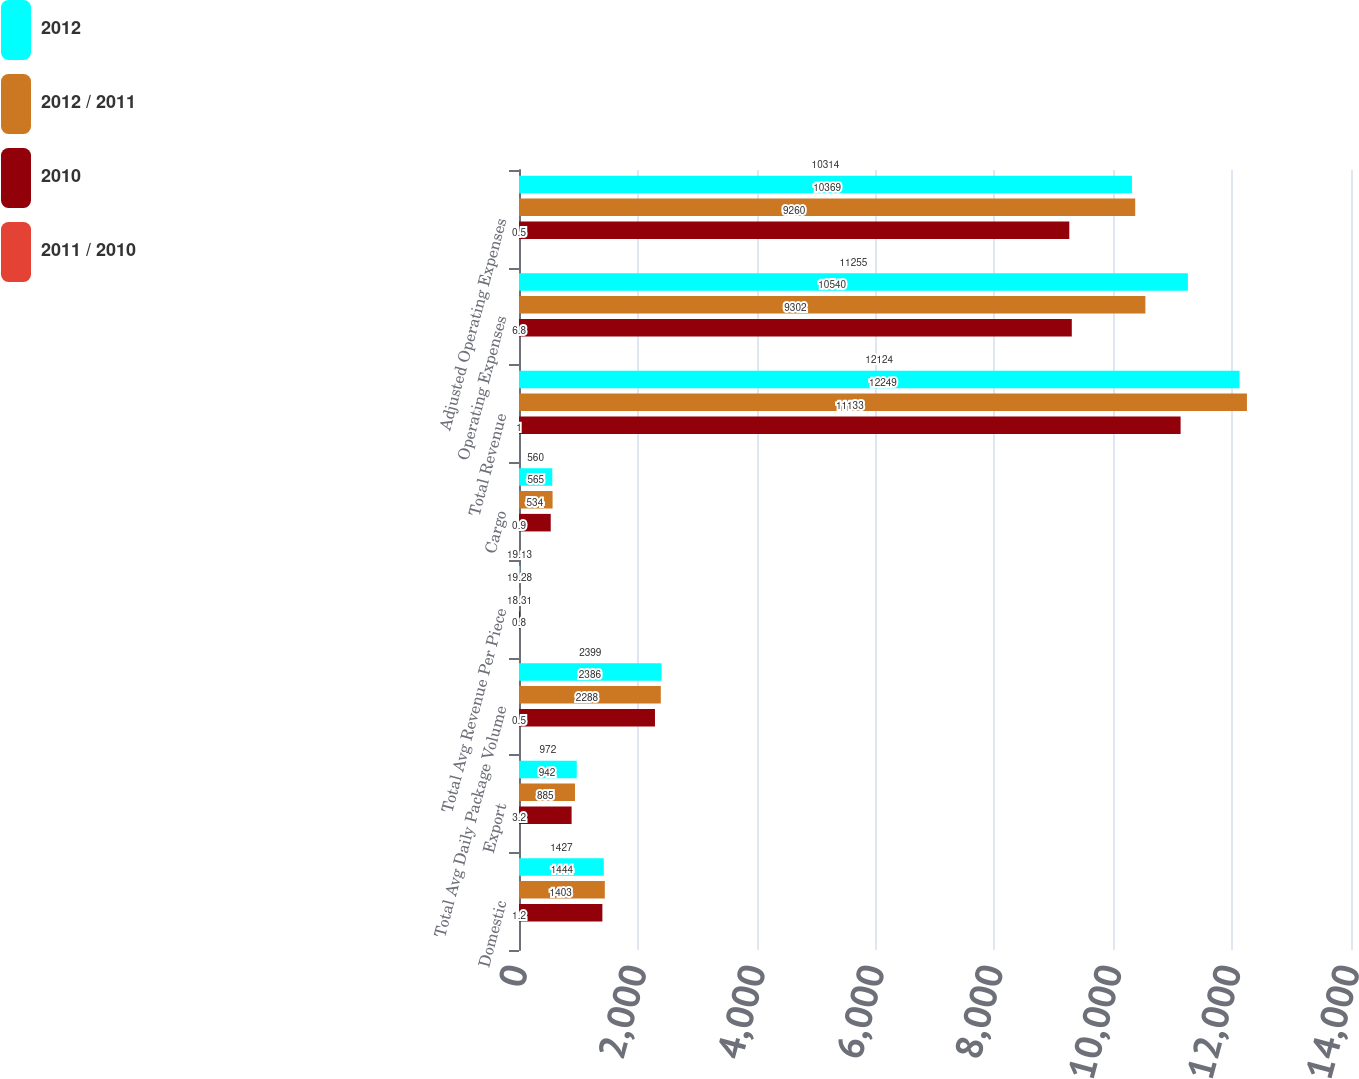Convert chart. <chart><loc_0><loc_0><loc_500><loc_500><stacked_bar_chart><ecel><fcel>Domestic<fcel>Export<fcel>Total Avg Daily Package Volume<fcel>Total Avg Revenue Per Piece<fcel>Cargo<fcel>Total Revenue<fcel>Operating Expenses<fcel>Adjusted Operating Expenses<nl><fcel>2012<fcel>1427<fcel>972<fcel>2399<fcel>19.13<fcel>560<fcel>12124<fcel>11255<fcel>10314<nl><fcel>2012 / 2011<fcel>1444<fcel>942<fcel>2386<fcel>19.28<fcel>565<fcel>12249<fcel>10540<fcel>10369<nl><fcel>2010<fcel>1403<fcel>885<fcel>2288<fcel>18.31<fcel>534<fcel>11133<fcel>9302<fcel>9260<nl><fcel>2011 / 2010<fcel>1.2<fcel>3.2<fcel>0.5<fcel>0.8<fcel>0.9<fcel>1<fcel>6.8<fcel>0.5<nl></chart> 